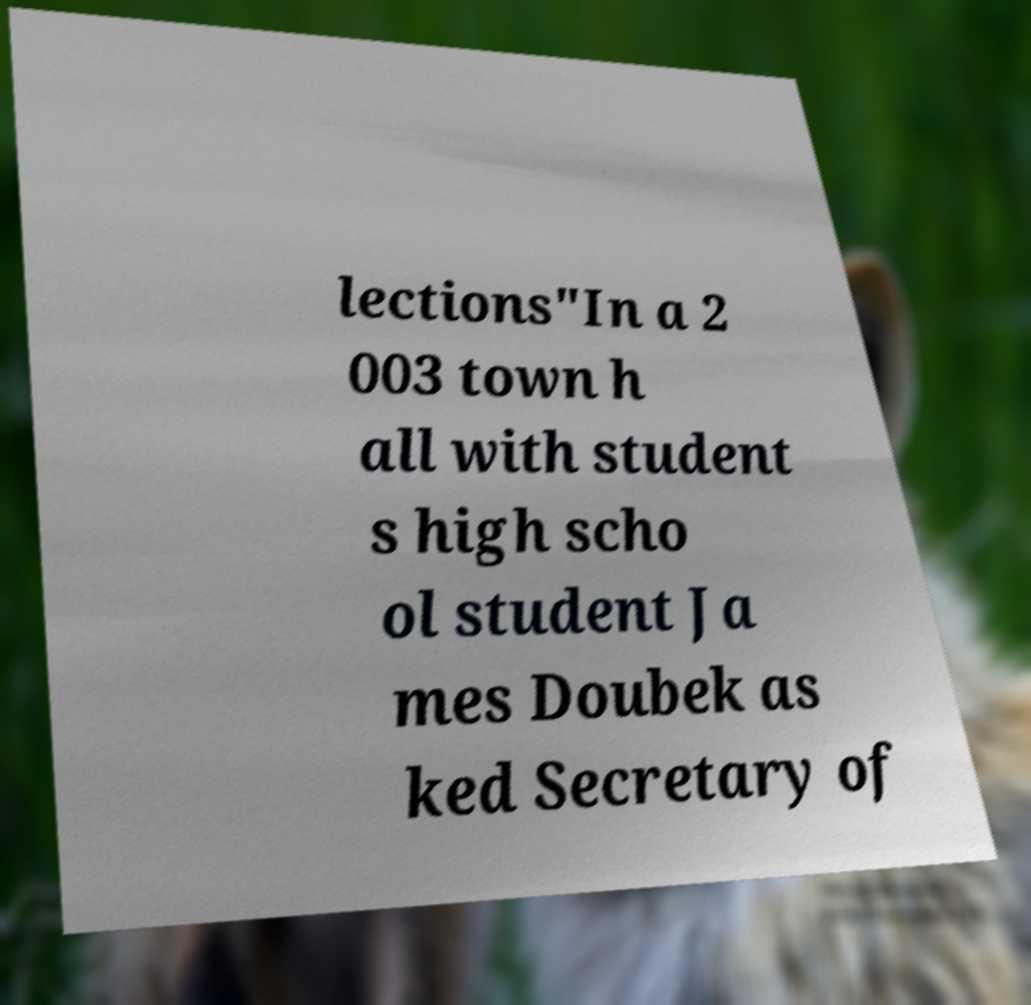I need the written content from this picture converted into text. Can you do that? lections"In a 2 003 town h all with student s high scho ol student Ja mes Doubek as ked Secretary of 